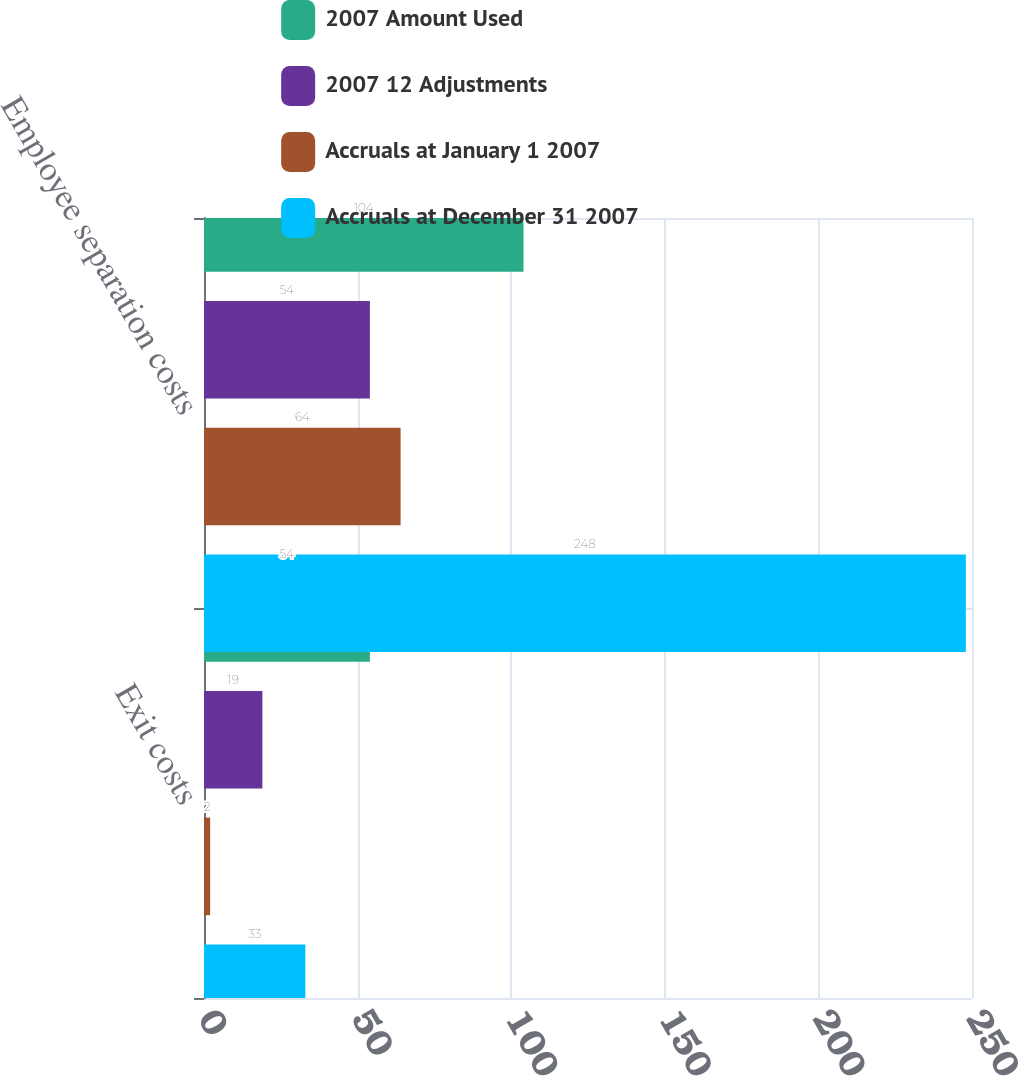Convert chart to OTSL. <chart><loc_0><loc_0><loc_500><loc_500><stacked_bar_chart><ecel><fcel>Exit costs<fcel>Employee separation costs<nl><fcel>2007 Amount Used<fcel>54<fcel>104<nl><fcel>2007 12 Adjustments<fcel>19<fcel>54<nl><fcel>Accruals at January 1 2007<fcel>2<fcel>64<nl><fcel>Accruals at December 31 2007<fcel>33<fcel>248<nl></chart> 